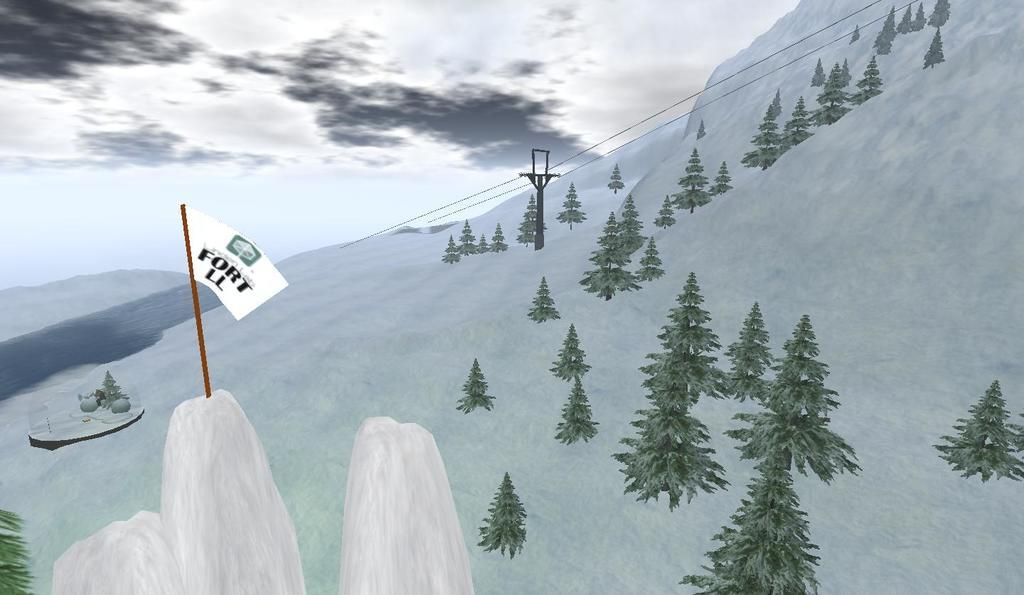What type of natural elements can be seen in the image? There are trees and hills visible in the image. What is the weather like in the image? The presence of clouds in the image suggests that it might be partly cloudy. What man-made structures are present in the image? There is an electric pole, cables, and a flag visible in the image. What is the primary element in the image? The sky is visible in the image. Reasoning: Let's think step by identifying the main subjects and objects in the image based on the provided facts. We then formulate questions that focus on the location and characteristics of these subjects and objects, ensuring that each question can be answered definitively with the information given. We avoid yes/no questions and ensure that the language is simple and clear. Absurd Question/Answer: Can you tell me how many times the achiever laughs while cracking a joke in the image? There is no achiever or any indication of someone laughing or cracking a joke in the image. 